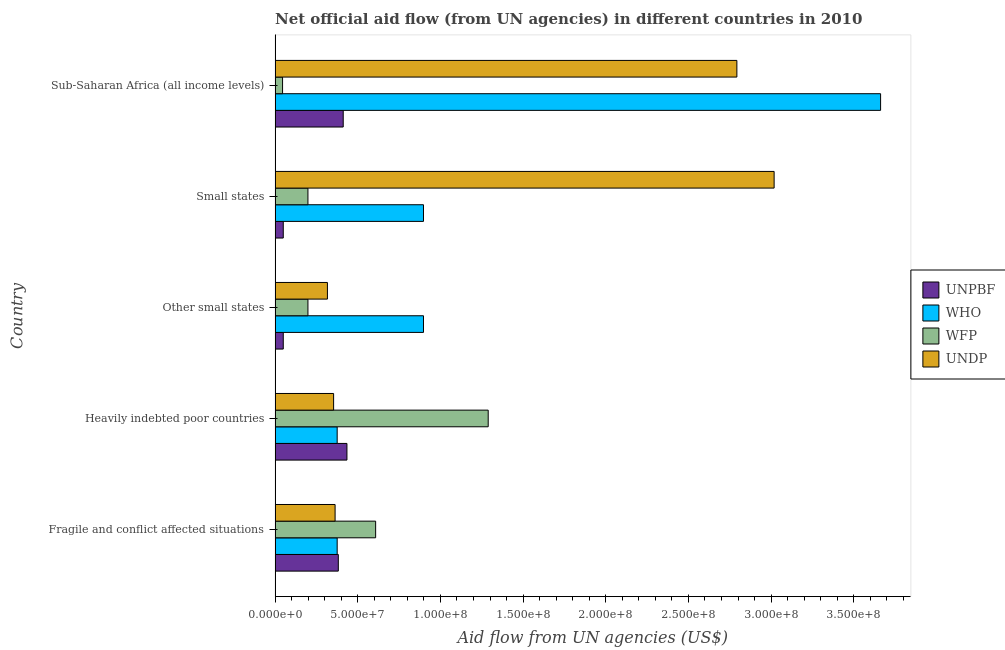How many groups of bars are there?
Provide a succinct answer. 5. Are the number of bars per tick equal to the number of legend labels?
Keep it short and to the point. Yes. What is the label of the 2nd group of bars from the top?
Ensure brevity in your answer.  Small states. In how many cases, is the number of bars for a given country not equal to the number of legend labels?
Give a very brief answer. 0. What is the amount of aid given by wfp in Fragile and conflict affected situations?
Provide a succinct answer. 6.08e+07. Across all countries, what is the maximum amount of aid given by who?
Provide a succinct answer. 3.66e+08. Across all countries, what is the minimum amount of aid given by who?
Make the answer very short. 3.76e+07. In which country was the amount of aid given by who maximum?
Provide a short and direct response. Sub-Saharan Africa (all income levels). In which country was the amount of aid given by undp minimum?
Make the answer very short. Other small states. What is the total amount of aid given by wfp in the graph?
Keep it short and to the point. 2.34e+08. What is the difference between the amount of aid given by undp in Other small states and that in Small states?
Ensure brevity in your answer.  -2.70e+08. What is the difference between the amount of aid given by who in Heavily indebted poor countries and the amount of aid given by undp in Other small states?
Provide a succinct answer. 5.90e+06. What is the average amount of aid given by wfp per country?
Provide a short and direct response. 4.68e+07. What is the difference between the amount of aid given by undp and amount of aid given by who in Other small states?
Make the answer very short. -5.81e+07. In how many countries, is the amount of aid given by wfp greater than 90000000 US$?
Provide a short and direct response. 1. Is the amount of aid given by wfp in Fragile and conflict affected situations less than that in Other small states?
Your answer should be compact. No. What is the difference between the highest and the second highest amount of aid given by unpbf?
Make the answer very short. 2.25e+06. What is the difference between the highest and the lowest amount of aid given by who?
Your answer should be compact. 3.29e+08. What does the 1st bar from the top in Fragile and conflict affected situations represents?
Provide a short and direct response. UNDP. What does the 3rd bar from the bottom in Fragile and conflict affected situations represents?
Make the answer very short. WFP. Is it the case that in every country, the sum of the amount of aid given by unpbf and amount of aid given by who is greater than the amount of aid given by wfp?
Your answer should be very brief. No. How many bars are there?
Your response must be concise. 20. Are all the bars in the graph horizontal?
Your response must be concise. Yes. What is the difference between two consecutive major ticks on the X-axis?
Offer a terse response. 5.00e+07. Are the values on the major ticks of X-axis written in scientific E-notation?
Your answer should be very brief. Yes. Does the graph contain grids?
Your answer should be compact. No. How many legend labels are there?
Give a very brief answer. 4. What is the title of the graph?
Ensure brevity in your answer.  Net official aid flow (from UN agencies) in different countries in 2010. What is the label or title of the X-axis?
Offer a very short reply. Aid flow from UN agencies (US$). What is the label or title of the Y-axis?
Give a very brief answer. Country. What is the Aid flow from UN agencies (US$) in UNPBF in Fragile and conflict affected situations?
Your response must be concise. 3.82e+07. What is the Aid flow from UN agencies (US$) of WHO in Fragile and conflict affected situations?
Provide a short and direct response. 3.76e+07. What is the Aid flow from UN agencies (US$) of WFP in Fragile and conflict affected situations?
Your answer should be very brief. 6.08e+07. What is the Aid flow from UN agencies (US$) of UNDP in Fragile and conflict affected situations?
Your answer should be compact. 3.63e+07. What is the Aid flow from UN agencies (US$) in UNPBF in Heavily indebted poor countries?
Give a very brief answer. 4.35e+07. What is the Aid flow from UN agencies (US$) in WHO in Heavily indebted poor countries?
Offer a very short reply. 3.76e+07. What is the Aid flow from UN agencies (US$) in WFP in Heavily indebted poor countries?
Offer a very short reply. 1.29e+08. What is the Aid flow from UN agencies (US$) of UNDP in Heavily indebted poor countries?
Your answer should be compact. 3.54e+07. What is the Aid flow from UN agencies (US$) in UNPBF in Other small states?
Provide a succinct answer. 4.95e+06. What is the Aid flow from UN agencies (US$) of WHO in Other small states?
Your response must be concise. 8.98e+07. What is the Aid flow from UN agencies (US$) of WFP in Other small states?
Provide a succinct answer. 1.99e+07. What is the Aid flow from UN agencies (US$) in UNDP in Other small states?
Your answer should be compact. 3.17e+07. What is the Aid flow from UN agencies (US$) of UNPBF in Small states?
Your answer should be compact. 4.95e+06. What is the Aid flow from UN agencies (US$) in WHO in Small states?
Offer a very short reply. 8.98e+07. What is the Aid flow from UN agencies (US$) in WFP in Small states?
Keep it short and to the point. 1.99e+07. What is the Aid flow from UN agencies (US$) of UNDP in Small states?
Provide a succinct answer. 3.02e+08. What is the Aid flow from UN agencies (US$) in UNPBF in Sub-Saharan Africa (all income levels)?
Your answer should be compact. 4.12e+07. What is the Aid flow from UN agencies (US$) of WHO in Sub-Saharan Africa (all income levels)?
Provide a succinct answer. 3.66e+08. What is the Aid flow from UN agencies (US$) of WFP in Sub-Saharan Africa (all income levels)?
Offer a terse response. 4.53e+06. What is the Aid flow from UN agencies (US$) in UNDP in Sub-Saharan Africa (all income levels)?
Provide a short and direct response. 2.79e+08. Across all countries, what is the maximum Aid flow from UN agencies (US$) in UNPBF?
Your answer should be very brief. 4.35e+07. Across all countries, what is the maximum Aid flow from UN agencies (US$) of WHO?
Give a very brief answer. 3.66e+08. Across all countries, what is the maximum Aid flow from UN agencies (US$) in WFP?
Provide a succinct answer. 1.29e+08. Across all countries, what is the maximum Aid flow from UN agencies (US$) of UNDP?
Your response must be concise. 3.02e+08. Across all countries, what is the minimum Aid flow from UN agencies (US$) in UNPBF?
Your answer should be compact. 4.95e+06. Across all countries, what is the minimum Aid flow from UN agencies (US$) of WHO?
Give a very brief answer. 3.76e+07. Across all countries, what is the minimum Aid flow from UN agencies (US$) in WFP?
Offer a very short reply. 4.53e+06. Across all countries, what is the minimum Aid flow from UN agencies (US$) of UNDP?
Give a very brief answer. 3.17e+07. What is the total Aid flow from UN agencies (US$) of UNPBF in the graph?
Your answer should be very brief. 1.33e+08. What is the total Aid flow from UN agencies (US$) of WHO in the graph?
Give a very brief answer. 6.21e+08. What is the total Aid flow from UN agencies (US$) in WFP in the graph?
Your answer should be very brief. 2.34e+08. What is the total Aid flow from UN agencies (US$) of UNDP in the graph?
Offer a very short reply. 6.85e+08. What is the difference between the Aid flow from UN agencies (US$) of UNPBF in Fragile and conflict affected situations and that in Heavily indebted poor countries?
Offer a very short reply. -5.21e+06. What is the difference between the Aid flow from UN agencies (US$) of WHO in Fragile and conflict affected situations and that in Heavily indebted poor countries?
Provide a succinct answer. 0. What is the difference between the Aid flow from UN agencies (US$) in WFP in Fragile and conflict affected situations and that in Heavily indebted poor countries?
Your response must be concise. -6.81e+07. What is the difference between the Aid flow from UN agencies (US$) in UNDP in Fragile and conflict affected situations and that in Heavily indebted poor countries?
Keep it short and to the point. 9.00e+05. What is the difference between the Aid flow from UN agencies (US$) of UNPBF in Fragile and conflict affected situations and that in Other small states?
Ensure brevity in your answer.  3.33e+07. What is the difference between the Aid flow from UN agencies (US$) in WHO in Fragile and conflict affected situations and that in Other small states?
Your answer should be compact. -5.22e+07. What is the difference between the Aid flow from UN agencies (US$) of WFP in Fragile and conflict affected situations and that in Other small states?
Keep it short and to the point. 4.10e+07. What is the difference between the Aid flow from UN agencies (US$) of UNDP in Fragile and conflict affected situations and that in Other small states?
Give a very brief answer. 4.64e+06. What is the difference between the Aid flow from UN agencies (US$) in UNPBF in Fragile and conflict affected situations and that in Small states?
Offer a terse response. 3.33e+07. What is the difference between the Aid flow from UN agencies (US$) of WHO in Fragile and conflict affected situations and that in Small states?
Your answer should be compact. -5.22e+07. What is the difference between the Aid flow from UN agencies (US$) in WFP in Fragile and conflict affected situations and that in Small states?
Provide a succinct answer. 4.10e+07. What is the difference between the Aid flow from UN agencies (US$) in UNDP in Fragile and conflict affected situations and that in Small states?
Offer a very short reply. -2.66e+08. What is the difference between the Aid flow from UN agencies (US$) of UNPBF in Fragile and conflict affected situations and that in Sub-Saharan Africa (all income levels)?
Make the answer very short. -2.96e+06. What is the difference between the Aid flow from UN agencies (US$) in WHO in Fragile and conflict affected situations and that in Sub-Saharan Africa (all income levels)?
Your answer should be very brief. -3.29e+08. What is the difference between the Aid flow from UN agencies (US$) in WFP in Fragile and conflict affected situations and that in Sub-Saharan Africa (all income levels)?
Keep it short and to the point. 5.63e+07. What is the difference between the Aid flow from UN agencies (US$) in UNDP in Fragile and conflict affected situations and that in Sub-Saharan Africa (all income levels)?
Provide a short and direct response. -2.43e+08. What is the difference between the Aid flow from UN agencies (US$) of UNPBF in Heavily indebted poor countries and that in Other small states?
Your answer should be very brief. 3.85e+07. What is the difference between the Aid flow from UN agencies (US$) in WHO in Heavily indebted poor countries and that in Other small states?
Provide a short and direct response. -5.22e+07. What is the difference between the Aid flow from UN agencies (US$) of WFP in Heavily indebted poor countries and that in Other small states?
Provide a short and direct response. 1.09e+08. What is the difference between the Aid flow from UN agencies (US$) of UNDP in Heavily indebted poor countries and that in Other small states?
Make the answer very short. 3.74e+06. What is the difference between the Aid flow from UN agencies (US$) of UNPBF in Heavily indebted poor countries and that in Small states?
Ensure brevity in your answer.  3.85e+07. What is the difference between the Aid flow from UN agencies (US$) of WHO in Heavily indebted poor countries and that in Small states?
Give a very brief answer. -5.22e+07. What is the difference between the Aid flow from UN agencies (US$) of WFP in Heavily indebted poor countries and that in Small states?
Keep it short and to the point. 1.09e+08. What is the difference between the Aid flow from UN agencies (US$) in UNDP in Heavily indebted poor countries and that in Small states?
Your answer should be compact. -2.66e+08. What is the difference between the Aid flow from UN agencies (US$) in UNPBF in Heavily indebted poor countries and that in Sub-Saharan Africa (all income levels)?
Provide a short and direct response. 2.25e+06. What is the difference between the Aid flow from UN agencies (US$) of WHO in Heavily indebted poor countries and that in Sub-Saharan Africa (all income levels)?
Your answer should be compact. -3.29e+08. What is the difference between the Aid flow from UN agencies (US$) of WFP in Heavily indebted poor countries and that in Sub-Saharan Africa (all income levels)?
Make the answer very short. 1.24e+08. What is the difference between the Aid flow from UN agencies (US$) in UNDP in Heavily indebted poor countries and that in Sub-Saharan Africa (all income levels)?
Provide a short and direct response. -2.44e+08. What is the difference between the Aid flow from UN agencies (US$) of UNPBF in Other small states and that in Small states?
Your response must be concise. 0. What is the difference between the Aid flow from UN agencies (US$) in WFP in Other small states and that in Small states?
Your answer should be very brief. 0. What is the difference between the Aid flow from UN agencies (US$) of UNDP in Other small states and that in Small states?
Provide a short and direct response. -2.70e+08. What is the difference between the Aid flow from UN agencies (US$) in UNPBF in Other small states and that in Sub-Saharan Africa (all income levels)?
Keep it short and to the point. -3.63e+07. What is the difference between the Aid flow from UN agencies (US$) of WHO in Other small states and that in Sub-Saharan Africa (all income levels)?
Provide a short and direct response. -2.76e+08. What is the difference between the Aid flow from UN agencies (US$) in WFP in Other small states and that in Sub-Saharan Africa (all income levels)?
Provide a succinct answer. 1.53e+07. What is the difference between the Aid flow from UN agencies (US$) in UNDP in Other small states and that in Sub-Saharan Africa (all income levels)?
Keep it short and to the point. -2.48e+08. What is the difference between the Aid flow from UN agencies (US$) of UNPBF in Small states and that in Sub-Saharan Africa (all income levels)?
Give a very brief answer. -3.63e+07. What is the difference between the Aid flow from UN agencies (US$) in WHO in Small states and that in Sub-Saharan Africa (all income levels)?
Provide a succinct answer. -2.76e+08. What is the difference between the Aid flow from UN agencies (US$) of WFP in Small states and that in Sub-Saharan Africa (all income levels)?
Give a very brief answer. 1.53e+07. What is the difference between the Aid flow from UN agencies (US$) in UNDP in Small states and that in Sub-Saharan Africa (all income levels)?
Provide a succinct answer. 2.25e+07. What is the difference between the Aid flow from UN agencies (US$) in UNPBF in Fragile and conflict affected situations and the Aid flow from UN agencies (US$) in WHO in Heavily indebted poor countries?
Ensure brevity in your answer.  6.90e+05. What is the difference between the Aid flow from UN agencies (US$) in UNPBF in Fragile and conflict affected situations and the Aid flow from UN agencies (US$) in WFP in Heavily indebted poor countries?
Your response must be concise. -9.07e+07. What is the difference between the Aid flow from UN agencies (US$) of UNPBF in Fragile and conflict affected situations and the Aid flow from UN agencies (US$) of UNDP in Heavily indebted poor countries?
Provide a short and direct response. 2.85e+06. What is the difference between the Aid flow from UN agencies (US$) in WHO in Fragile and conflict affected situations and the Aid flow from UN agencies (US$) in WFP in Heavily indebted poor countries?
Provide a short and direct response. -9.14e+07. What is the difference between the Aid flow from UN agencies (US$) of WHO in Fragile and conflict affected situations and the Aid flow from UN agencies (US$) of UNDP in Heavily indebted poor countries?
Make the answer very short. 2.16e+06. What is the difference between the Aid flow from UN agencies (US$) of WFP in Fragile and conflict affected situations and the Aid flow from UN agencies (US$) of UNDP in Heavily indebted poor countries?
Provide a succinct answer. 2.54e+07. What is the difference between the Aid flow from UN agencies (US$) in UNPBF in Fragile and conflict affected situations and the Aid flow from UN agencies (US$) in WHO in Other small states?
Your answer should be compact. -5.15e+07. What is the difference between the Aid flow from UN agencies (US$) of UNPBF in Fragile and conflict affected situations and the Aid flow from UN agencies (US$) of WFP in Other small states?
Your answer should be compact. 1.84e+07. What is the difference between the Aid flow from UN agencies (US$) in UNPBF in Fragile and conflict affected situations and the Aid flow from UN agencies (US$) in UNDP in Other small states?
Offer a very short reply. 6.59e+06. What is the difference between the Aid flow from UN agencies (US$) of WHO in Fragile and conflict affected situations and the Aid flow from UN agencies (US$) of WFP in Other small states?
Make the answer very short. 1.77e+07. What is the difference between the Aid flow from UN agencies (US$) of WHO in Fragile and conflict affected situations and the Aid flow from UN agencies (US$) of UNDP in Other small states?
Your response must be concise. 5.90e+06. What is the difference between the Aid flow from UN agencies (US$) of WFP in Fragile and conflict affected situations and the Aid flow from UN agencies (US$) of UNDP in Other small states?
Provide a succinct answer. 2.92e+07. What is the difference between the Aid flow from UN agencies (US$) of UNPBF in Fragile and conflict affected situations and the Aid flow from UN agencies (US$) of WHO in Small states?
Your response must be concise. -5.15e+07. What is the difference between the Aid flow from UN agencies (US$) in UNPBF in Fragile and conflict affected situations and the Aid flow from UN agencies (US$) in WFP in Small states?
Give a very brief answer. 1.84e+07. What is the difference between the Aid flow from UN agencies (US$) of UNPBF in Fragile and conflict affected situations and the Aid flow from UN agencies (US$) of UNDP in Small states?
Your response must be concise. -2.64e+08. What is the difference between the Aid flow from UN agencies (US$) of WHO in Fragile and conflict affected situations and the Aid flow from UN agencies (US$) of WFP in Small states?
Keep it short and to the point. 1.77e+07. What is the difference between the Aid flow from UN agencies (US$) of WHO in Fragile and conflict affected situations and the Aid flow from UN agencies (US$) of UNDP in Small states?
Make the answer very short. -2.64e+08. What is the difference between the Aid flow from UN agencies (US$) of WFP in Fragile and conflict affected situations and the Aid flow from UN agencies (US$) of UNDP in Small states?
Your response must be concise. -2.41e+08. What is the difference between the Aid flow from UN agencies (US$) in UNPBF in Fragile and conflict affected situations and the Aid flow from UN agencies (US$) in WHO in Sub-Saharan Africa (all income levels)?
Give a very brief answer. -3.28e+08. What is the difference between the Aid flow from UN agencies (US$) in UNPBF in Fragile and conflict affected situations and the Aid flow from UN agencies (US$) in WFP in Sub-Saharan Africa (all income levels)?
Make the answer very short. 3.37e+07. What is the difference between the Aid flow from UN agencies (US$) of UNPBF in Fragile and conflict affected situations and the Aid flow from UN agencies (US$) of UNDP in Sub-Saharan Africa (all income levels)?
Your answer should be compact. -2.41e+08. What is the difference between the Aid flow from UN agencies (US$) of WHO in Fragile and conflict affected situations and the Aid flow from UN agencies (US$) of WFP in Sub-Saharan Africa (all income levels)?
Provide a short and direct response. 3.30e+07. What is the difference between the Aid flow from UN agencies (US$) of WHO in Fragile and conflict affected situations and the Aid flow from UN agencies (US$) of UNDP in Sub-Saharan Africa (all income levels)?
Keep it short and to the point. -2.42e+08. What is the difference between the Aid flow from UN agencies (US$) in WFP in Fragile and conflict affected situations and the Aid flow from UN agencies (US$) in UNDP in Sub-Saharan Africa (all income levels)?
Make the answer very short. -2.18e+08. What is the difference between the Aid flow from UN agencies (US$) of UNPBF in Heavily indebted poor countries and the Aid flow from UN agencies (US$) of WHO in Other small states?
Make the answer very short. -4.63e+07. What is the difference between the Aid flow from UN agencies (US$) in UNPBF in Heavily indebted poor countries and the Aid flow from UN agencies (US$) in WFP in Other small states?
Offer a terse response. 2.36e+07. What is the difference between the Aid flow from UN agencies (US$) in UNPBF in Heavily indebted poor countries and the Aid flow from UN agencies (US$) in UNDP in Other small states?
Give a very brief answer. 1.18e+07. What is the difference between the Aid flow from UN agencies (US$) of WHO in Heavily indebted poor countries and the Aid flow from UN agencies (US$) of WFP in Other small states?
Ensure brevity in your answer.  1.77e+07. What is the difference between the Aid flow from UN agencies (US$) in WHO in Heavily indebted poor countries and the Aid flow from UN agencies (US$) in UNDP in Other small states?
Your answer should be very brief. 5.90e+06. What is the difference between the Aid flow from UN agencies (US$) of WFP in Heavily indebted poor countries and the Aid flow from UN agencies (US$) of UNDP in Other small states?
Your answer should be compact. 9.72e+07. What is the difference between the Aid flow from UN agencies (US$) in UNPBF in Heavily indebted poor countries and the Aid flow from UN agencies (US$) in WHO in Small states?
Give a very brief answer. -4.63e+07. What is the difference between the Aid flow from UN agencies (US$) of UNPBF in Heavily indebted poor countries and the Aid flow from UN agencies (US$) of WFP in Small states?
Offer a very short reply. 2.36e+07. What is the difference between the Aid flow from UN agencies (US$) of UNPBF in Heavily indebted poor countries and the Aid flow from UN agencies (US$) of UNDP in Small states?
Your answer should be very brief. -2.58e+08. What is the difference between the Aid flow from UN agencies (US$) in WHO in Heavily indebted poor countries and the Aid flow from UN agencies (US$) in WFP in Small states?
Your answer should be very brief. 1.77e+07. What is the difference between the Aid flow from UN agencies (US$) of WHO in Heavily indebted poor countries and the Aid flow from UN agencies (US$) of UNDP in Small states?
Your answer should be very brief. -2.64e+08. What is the difference between the Aid flow from UN agencies (US$) of WFP in Heavily indebted poor countries and the Aid flow from UN agencies (US$) of UNDP in Small states?
Give a very brief answer. -1.73e+08. What is the difference between the Aid flow from UN agencies (US$) of UNPBF in Heavily indebted poor countries and the Aid flow from UN agencies (US$) of WHO in Sub-Saharan Africa (all income levels)?
Provide a short and direct response. -3.23e+08. What is the difference between the Aid flow from UN agencies (US$) of UNPBF in Heavily indebted poor countries and the Aid flow from UN agencies (US$) of WFP in Sub-Saharan Africa (all income levels)?
Keep it short and to the point. 3.89e+07. What is the difference between the Aid flow from UN agencies (US$) of UNPBF in Heavily indebted poor countries and the Aid flow from UN agencies (US$) of UNDP in Sub-Saharan Africa (all income levels)?
Keep it short and to the point. -2.36e+08. What is the difference between the Aid flow from UN agencies (US$) in WHO in Heavily indebted poor countries and the Aid flow from UN agencies (US$) in WFP in Sub-Saharan Africa (all income levels)?
Your answer should be very brief. 3.30e+07. What is the difference between the Aid flow from UN agencies (US$) of WHO in Heavily indebted poor countries and the Aid flow from UN agencies (US$) of UNDP in Sub-Saharan Africa (all income levels)?
Provide a short and direct response. -2.42e+08. What is the difference between the Aid flow from UN agencies (US$) in WFP in Heavily indebted poor countries and the Aid flow from UN agencies (US$) in UNDP in Sub-Saharan Africa (all income levels)?
Keep it short and to the point. -1.50e+08. What is the difference between the Aid flow from UN agencies (US$) of UNPBF in Other small states and the Aid flow from UN agencies (US$) of WHO in Small states?
Make the answer very short. -8.48e+07. What is the difference between the Aid flow from UN agencies (US$) of UNPBF in Other small states and the Aid flow from UN agencies (US$) of WFP in Small states?
Offer a very short reply. -1.49e+07. What is the difference between the Aid flow from UN agencies (US$) of UNPBF in Other small states and the Aid flow from UN agencies (US$) of UNDP in Small states?
Make the answer very short. -2.97e+08. What is the difference between the Aid flow from UN agencies (US$) in WHO in Other small states and the Aid flow from UN agencies (US$) in WFP in Small states?
Give a very brief answer. 6.99e+07. What is the difference between the Aid flow from UN agencies (US$) of WHO in Other small states and the Aid flow from UN agencies (US$) of UNDP in Small states?
Keep it short and to the point. -2.12e+08. What is the difference between the Aid flow from UN agencies (US$) of WFP in Other small states and the Aid flow from UN agencies (US$) of UNDP in Small states?
Offer a very short reply. -2.82e+08. What is the difference between the Aid flow from UN agencies (US$) of UNPBF in Other small states and the Aid flow from UN agencies (US$) of WHO in Sub-Saharan Africa (all income levels)?
Your answer should be very brief. -3.61e+08. What is the difference between the Aid flow from UN agencies (US$) of UNPBF in Other small states and the Aid flow from UN agencies (US$) of UNDP in Sub-Saharan Africa (all income levels)?
Provide a succinct answer. -2.74e+08. What is the difference between the Aid flow from UN agencies (US$) in WHO in Other small states and the Aid flow from UN agencies (US$) in WFP in Sub-Saharan Africa (all income levels)?
Offer a very short reply. 8.52e+07. What is the difference between the Aid flow from UN agencies (US$) of WHO in Other small states and the Aid flow from UN agencies (US$) of UNDP in Sub-Saharan Africa (all income levels)?
Keep it short and to the point. -1.90e+08. What is the difference between the Aid flow from UN agencies (US$) in WFP in Other small states and the Aid flow from UN agencies (US$) in UNDP in Sub-Saharan Africa (all income levels)?
Keep it short and to the point. -2.59e+08. What is the difference between the Aid flow from UN agencies (US$) in UNPBF in Small states and the Aid flow from UN agencies (US$) in WHO in Sub-Saharan Africa (all income levels)?
Ensure brevity in your answer.  -3.61e+08. What is the difference between the Aid flow from UN agencies (US$) of UNPBF in Small states and the Aid flow from UN agencies (US$) of WFP in Sub-Saharan Africa (all income levels)?
Your answer should be very brief. 4.20e+05. What is the difference between the Aid flow from UN agencies (US$) of UNPBF in Small states and the Aid flow from UN agencies (US$) of UNDP in Sub-Saharan Africa (all income levels)?
Offer a very short reply. -2.74e+08. What is the difference between the Aid flow from UN agencies (US$) of WHO in Small states and the Aid flow from UN agencies (US$) of WFP in Sub-Saharan Africa (all income levels)?
Keep it short and to the point. 8.52e+07. What is the difference between the Aid flow from UN agencies (US$) in WHO in Small states and the Aid flow from UN agencies (US$) in UNDP in Sub-Saharan Africa (all income levels)?
Your response must be concise. -1.90e+08. What is the difference between the Aid flow from UN agencies (US$) of WFP in Small states and the Aid flow from UN agencies (US$) of UNDP in Sub-Saharan Africa (all income levels)?
Ensure brevity in your answer.  -2.59e+08. What is the average Aid flow from UN agencies (US$) of UNPBF per country?
Make the answer very short. 2.66e+07. What is the average Aid flow from UN agencies (US$) of WHO per country?
Ensure brevity in your answer.  1.24e+08. What is the average Aid flow from UN agencies (US$) in WFP per country?
Your answer should be compact. 4.68e+07. What is the average Aid flow from UN agencies (US$) in UNDP per country?
Give a very brief answer. 1.37e+08. What is the difference between the Aid flow from UN agencies (US$) of UNPBF and Aid flow from UN agencies (US$) of WHO in Fragile and conflict affected situations?
Provide a succinct answer. 6.90e+05. What is the difference between the Aid flow from UN agencies (US$) of UNPBF and Aid flow from UN agencies (US$) of WFP in Fragile and conflict affected situations?
Your answer should be compact. -2.26e+07. What is the difference between the Aid flow from UN agencies (US$) in UNPBF and Aid flow from UN agencies (US$) in UNDP in Fragile and conflict affected situations?
Give a very brief answer. 1.95e+06. What is the difference between the Aid flow from UN agencies (US$) of WHO and Aid flow from UN agencies (US$) of WFP in Fragile and conflict affected situations?
Keep it short and to the point. -2.33e+07. What is the difference between the Aid flow from UN agencies (US$) in WHO and Aid flow from UN agencies (US$) in UNDP in Fragile and conflict affected situations?
Ensure brevity in your answer.  1.26e+06. What is the difference between the Aid flow from UN agencies (US$) of WFP and Aid flow from UN agencies (US$) of UNDP in Fragile and conflict affected situations?
Your response must be concise. 2.45e+07. What is the difference between the Aid flow from UN agencies (US$) in UNPBF and Aid flow from UN agencies (US$) in WHO in Heavily indebted poor countries?
Your answer should be compact. 5.90e+06. What is the difference between the Aid flow from UN agencies (US$) of UNPBF and Aid flow from UN agencies (US$) of WFP in Heavily indebted poor countries?
Ensure brevity in your answer.  -8.54e+07. What is the difference between the Aid flow from UN agencies (US$) of UNPBF and Aid flow from UN agencies (US$) of UNDP in Heavily indebted poor countries?
Your answer should be very brief. 8.06e+06. What is the difference between the Aid flow from UN agencies (US$) of WHO and Aid flow from UN agencies (US$) of WFP in Heavily indebted poor countries?
Offer a very short reply. -9.14e+07. What is the difference between the Aid flow from UN agencies (US$) in WHO and Aid flow from UN agencies (US$) in UNDP in Heavily indebted poor countries?
Provide a succinct answer. 2.16e+06. What is the difference between the Aid flow from UN agencies (US$) of WFP and Aid flow from UN agencies (US$) of UNDP in Heavily indebted poor countries?
Keep it short and to the point. 9.35e+07. What is the difference between the Aid flow from UN agencies (US$) in UNPBF and Aid flow from UN agencies (US$) in WHO in Other small states?
Make the answer very short. -8.48e+07. What is the difference between the Aid flow from UN agencies (US$) in UNPBF and Aid flow from UN agencies (US$) in WFP in Other small states?
Your response must be concise. -1.49e+07. What is the difference between the Aid flow from UN agencies (US$) in UNPBF and Aid flow from UN agencies (US$) in UNDP in Other small states?
Give a very brief answer. -2.67e+07. What is the difference between the Aid flow from UN agencies (US$) in WHO and Aid flow from UN agencies (US$) in WFP in Other small states?
Keep it short and to the point. 6.99e+07. What is the difference between the Aid flow from UN agencies (US$) in WHO and Aid flow from UN agencies (US$) in UNDP in Other small states?
Provide a short and direct response. 5.81e+07. What is the difference between the Aid flow from UN agencies (US$) of WFP and Aid flow from UN agencies (US$) of UNDP in Other small states?
Make the answer very short. -1.18e+07. What is the difference between the Aid flow from UN agencies (US$) of UNPBF and Aid flow from UN agencies (US$) of WHO in Small states?
Provide a short and direct response. -8.48e+07. What is the difference between the Aid flow from UN agencies (US$) of UNPBF and Aid flow from UN agencies (US$) of WFP in Small states?
Offer a terse response. -1.49e+07. What is the difference between the Aid flow from UN agencies (US$) of UNPBF and Aid flow from UN agencies (US$) of UNDP in Small states?
Make the answer very short. -2.97e+08. What is the difference between the Aid flow from UN agencies (US$) in WHO and Aid flow from UN agencies (US$) in WFP in Small states?
Offer a terse response. 6.99e+07. What is the difference between the Aid flow from UN agencies (US$) of WHO and Aid flow from UN agencies (US$) of UNDP in Small states?
Ensure brevity in your answer.  -2.12e+08. What is the difference between the Aid flow from UN agencies (US$) in WFP and Aid flow from UN agencies (US$) in UNDP in Small states?
Offer a terse response. -2.82e+08. What is the difference between the Aid flow from UN agencies (US$) in UNPBF and Aid flow from UN agencies (US$) in WHO in Sub-Saharan Africa (all income levels)?
Your response must be concise. -3.25e+08. What is the difference between the Aid flow from UN agencies (US$) in UNPBF and Aid flow from UN agencies (US$) in WFP in Sub-Saharan Africa (all income levels)?
Keep it short and to the point. 3.67e+07. What is the difference between the Aid flow from UN agencies (US$) in UNPBF and Aid flow from UN agencies (US$) in UNDP in Sub-Saharan Africa (all income levels)?
Provide a short and direct response. -2.38e+08. What is the difference between the Aid flow from UN agencies (US$) in WHO and Aid flow from UN agencies (US$) in WFP in Sub-Saharan Africa (all income levels)?
Your answer should be compact. 3.62e+08. What is the difference between the Aid flow from UN agencies (US$) in WHO and Aid flow from UN agencies (US$) in UNDP in Sub-Saharan Africa (all income levels)?
Provide a succinct answer. 8.69e+07. What is the difference between the Aid flow from UN agencies (US$) in WFP and Aid flow from UN agencies (US$) in UNDP in Sub-Saharan Africa (all income levels)?
Give a very brief answer. -2.75e+08. What is the ratio of the Aid flow from UN agencies (US$) in UNPBF in Fragile and conflict affected situations to that in Heavily indebted poor countries?
Provide a short and direct response. 0.88. What is the ratio of the Aid flow from UN agencies (US$) in WFP in Fragile and conflict affected situations to that in Heavily indebted poor countries?
Make the answer very short. 0.47. What is the ratio of the Aid flow from UN agencies (US$) in UNDP in Fragile and conflict affected situations to that in Heavily indebted poor countries?
Offer a very short reply. 1.03. What is the ratio of the Aid flow from UN agencies (US$) of UNPBF in Fragile and conflict affected situations to that in Other small states?
Offer a very short reply. 7.73. What is the ratio of the Aid flow from UN agencies (US$) of WHO in Fragile and conflict affected situations to that in Other small states?
Offer a terse response. 0.42. What is the ratio of the Aid flow from UN agencies (US$) of WFP in Fragile and conflict affected situations to that in Other small states?
Provide a short and direct response. 3.06. What is the ratio of the Aid flow from UN agencies (US$) in UNDP in Fragile and conflict affected situations to that in Other small states?
Provide a short and direct response. 1.15. What is the ratio of the Aid flow from UN agencies (US$) in UNPBF in Fragile and conflict affected situations to that in Small states?
Offer a very short reply. 7.73. What is the ratio of the Aid flow from UN agencies (US$) in WHO in Fragile and conflict affected situations to that in Small states?
Your answer should be very brief. 0.42. What is the ratio of the Aid flow from UN agencies (US$) of WFP in Fragile and conflict affected situations to that in Small states?
Give a very brief answer. 3.06. What is the ratio of the Aid flow from UN agencies (US$) in UNDP in Fragile and conflict affected situations to that in Small states?
Ensure brevity in your answer.  0.12. What is the ratio of the Aid flow from UN agencies (US$) of UNPBF in Fragile and conflict affected situations to that in Sub-Saharan Africa (all income levels)?
Give a very brief answer. 0.93. What is the ratio of the Aid flow from UN agencies (US$) in WHO in Fragile and conflict affected situations to that in Sub-Saharan Africa (all income levels)?
Your answer should be compact. 0.1. What is the ratio of the Aid flow from UN agencies (US$) in WFP in Fragile and conflict affected situations to that in Sub-Saharan Africa (all income levels)?
Keep it short and to the point. 13.43. What is the ratio of the Aid flow from UN agencies (US$) in UNDP in Fragile and conflict affected situations to that in Sub-Saharan Africa (all income levels)?
Keep it short and to the point. 0.13. What is the ratio of the Aid flow from UN agencies (US$) of UNPBF in Heavily indebted poor countries to that in Other small states?
Offer a very short reply. 8.78. What is the ratio of the Aid flow from UN agencies (US$) of WHO in Heavily indebted poor countries to that in Other small states?
Offer a very short reply. 0.42. What is the ratio of the Aid flow from UN agencies (US$) of WFP in Heavily indebted poor countries to that in Other small states?
Your answer should be very brief. 6.49. What is the ratio of the Aid flow from UN agencies (US$) in UNDP in Heavily indebted poor countries to that in Other small states?
Keep it short and to the point. 1.12. What is the ratio of the Aid flow from UN agencies (US$) of UNPBF in Heavily indebted poor countries to that in Small states?
Your response must be concise. 8.78. What is the ratio of the Aid flow from UN agencies (US$) of WHO in Heavily indebted poor countries to that in Small states?
Your answer should be very brief. 0.42. What is the ratio of the Aid flow from UN agencies (US$) of WFP in Heavily indebted poor countries to that in Small states?
Keep it short and to the point. 6.49. What is the ratio of the Aid flow from UN agencies (US$) in UNDP in Heavily indebted poor countries to that in Small states?
Keep it short and to the point. 0.12. What is the ratio of the Aid flow from UN agencies (US$) in UNPBF in Heavily indebted poor countries to that in Sub-Saharan Africa (all income levels)?
Make the answer very short. 1.05. What is the ratio of the Aid flow from UN agencies (US$) of WHO in Heavily indebted poor countries to that in Sub-Saharan Africa (all income levels)?
Keep it short and to the point. 0.1. What is the ratio of the Aid flow from UN agencies (US$) of WFP in Heavily indebted poor countries to that in Sub-Saharan Africa (all income levels)?
Provide a short and direct response. 28.46. What is the ratio of the Aid flow from UN agencies (US$) of UNDP in Heavily indebted poor countries to that in Sub-Saharan Africa (all income levels)?
Make the answer very short. 0.13. What is the ratio of the Aid flow from UN agencies (US$) of WHO in Other small states to that in Small states?
Make the answer very short. 1. What is the ratio of the Aid flow from UN agencies (US$) in UNDP in Other small states to that in Small states?
Your answer should be compact. 0.1. What is the ratio of the Aid flow from UN agencies (US$) in UNPBF in Other small states to that in Sub-Saharan Africa (all income levels)?
Offer a terse response. 0.12. What is the ratio of the Aid flow from UN agencies (US$) in WHO in Other small states to that in Sub-Saharan Africa (all income levels)?
Make the answer very short. 0.25. What is the ratio of the Aid flow from UN agencies (US$) in WFP in Other small states to that in Sub-Saharan Africa (all income levels)?
Your answer should be very brief. 4.39. What is the ratio of the Aid flow from UN agencies (US$) of UNDP in Other small states to that in Sub-Saharan Africa (all income levels)?
Give a very brief answer. 0.11. What is the ratio of the Aid flow from UN agencies (US$) in UNPBF in Small states to that in Sub-Saharan Africa (all income levels)?
Make the answer very short. 0.12. What is the ratio of the Aid flow from UN agencies (US$) in WHO in Small states to that in Sub-Saharan Africa (all income levels)?
Provide a short and direct response. 0.25. What is the ratio of the Aid flow from UN agencies (US$) of WFP in Small states to that in Sub-Saharan Africa (all income levels)?
Provide a succinct answer. 4.39. What is the ratio of the Aid flow from UN agencies (US$) in UNDP in Small states to that in Sub-Saharan Africa (all income levels)?
Offer a very short reply. 1.08. What is the difference between the highest and the second highest Aid flow from UN agencies (US$) in UNPBF?
Give a very brief answer. 2.25e+06. What is the difference between the highest and the second highest Aid flow from UN agencies (US$) in WHO?
Offer a terse response. 2.76e+08. What is the difference between the highest and the second highest Aid flow from UN agencies (US$) of WFP?
Your response must be concise. 6.81e+07. What is the difference between the highest and the second highest Aid flow from UN agencies (US$) in UNDP?
Provide a short and direct response. 2.25e+07. What is the difference between the highest and the lowest Aid flow from UN agencies (US$) of UNPBF?
Offer a terse response. 3.85e+07. What is the difference between the highest and the lowest Aid flow from UN agencies (US$) in WHO?
Ensure brevity in your answer.  3.29e+08. What is the difference between the highest and the lowest Aid flow from UN agencies (US$) in WFP?
Your response must be concise. 1.24e+08. What is the difference between the highest and the lowest Aid flow from UN agencies (US$) of UNDP?
Offer a very short reply. 2.70e+08. 